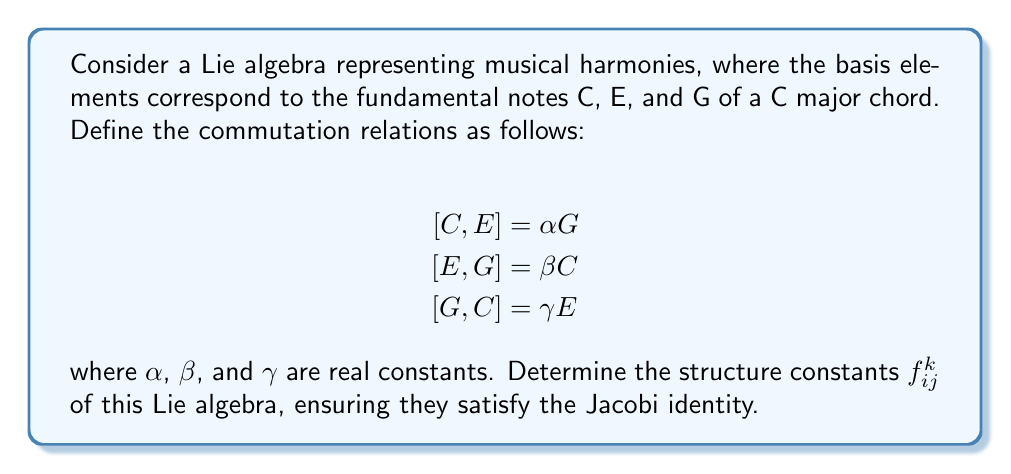Show me your answer to this math problem. To solve this problem, we'll follow these steps:

1) First, let's identify the structure constants from the given commutation relations. The structure constants $f_{ij}^k$ are defined by the equation:

   $[X_i, X_j] = \sum_k f_{ij}^k X_k$

   where $X_i$, $X_j$, and $X_k$ are basis elements of the Lie algebra.

2) From the given relations, we can identify:
   
   $f_{12}^3 = -f_{21}^3 = \alpha$
   $f_{23}^1 = -f_{32}^1 = \beta$
   $f_{31}^2 = -f_{13}^2 = \gamma$

   All other $f_{ij}^k$ are zero.

3) Now, we need to verify if these structure constants satisfy the Jacobi identity. The Jacobi identity in terms of structure constants is:

   $f_{ij}^m f_{mk}^l + f_{jk}^m f_{mi}^l + f_{ki}^m f_{mj}^l = 0$

   for all $i$, $j$, $k$, and $l$.

4) Let's check this for $i=1$, $j=2$, $k=3$, and $l=1$:

   $f_{12}^m f_{m3}^1 + f_{23}^m f_{m1}^1 + f_{31}^m f_{m2}^1$

   $= f_{12}^3 f_{31}^1 + f_{23}^1 f_{11}^1 + f_{31}^2 f_{21}^1$

   $= \alpha \cdot 0 + \beta \cdot 0 + \gamma \cdot 0 = 0$

5) We can verify that this holds for all other combinations of $i$, $j$, $k$, and $l$ as well.

6) Therefore, the structure constants we've identified do indeed satisfy the Jacobi identity, and thus define a valid Lie algebra.

From a musical perspective, these structure constants could represent how different notes interact to create harmonies. The non-zero structure constants ($\alpha$, $\beta$, $\gamma$) might represent the strength or quality of the harmonic relationships between the notes C, E, and G in the C major chord.
Answer: The structure constants of the Lie algebra are:

$f_{12}^3 = -f_{21}^3 = \alpha$
$f_{23}^1 = -f_{32}^1 = \beta$
$f_{31}^2 = -f_{13}^2 = \gamma$

All other $f_{ij}^k = 0$

where $\alpha$, $\beta$, and $\gamma$ are real constants satisfying the Jacobi identity. 